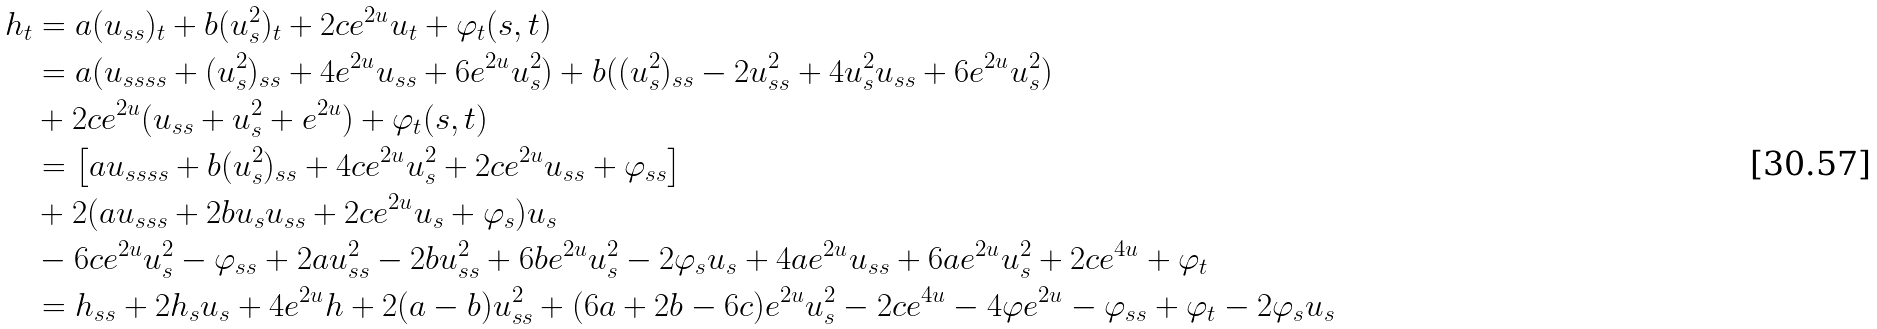Convert formula to latex. <formula><loc_0><loc_0><loc_500><loc_500>h _ { t } & = a ( u _ { s s } ) _ { t } + b ( u _ { s } ^ { 2 } ) _ { t } + 2 c e ^ { 2 u } u _ { t } + \varphi _ { t } ( s , t ) \\ & = a ( u _ { s s s s } + ( u _ { s } ^ { 2 } ) _ { s s } + 4 e ^ { 2 u } u _ { s s } + 6 e ^ { 2 u } u _ { s } ^ { 2 } ) + b ( ( u _ { s } ^ { 2 } ) _ { s s } - 2 u _ { s s } ^ { 2 } + 4 u _ { s } ^ { 2 } u _ { s s } + 6 e ^ { 2 u } u _ { s } ^ { 2 } ) \\ & + 2 c e ^ { 2 u } ( u _ { s s } + u _ { s } ^ { 2 } + e ^ { 2 u } ) + \varphi _ { t } ( s , t ) \\ & = \left [ a u _ { s s s s } + b ( u _ { s } ^ { 2 } ) _ { s s } + 4 c e ^ { 2 u } u _ { s } ^ { 2 } + 2 c e ^ { 2 u } u _ { s s } + \varphi _ { s s } \right ] \\ & + 2 ( a u _ { s s s } + 2 b u _ { s } u _ { s s } + 2 c e ^ { 2 u } u _ { s } + \varphi _ { s } ) u _ { s } \\ & - 6 c e ^ { 2 u } u _ { s } ^ { 2 } - \varphi _ { s s } + 2 a u _ { s s } ^ { 2 } - 2 b u _ { s s } ^ { 2 } + 6 b e ^ { 2 u } u _ { s } ^ { 2 } - 2 \varphi _ { s } u _ { s } + 4 a e ^ { 2 u } u _ { s s } + 6 a e ^ { 2 u } u _ { s } ^ { 2 } + 2 c e ^ { 4 u } + \varphi _ { t } \\ & = h _ { s s } + 2 h _ { s } u _ { s } + 4 e ^ { 2 u } h + 2 ( a - b ) u _ { s s } ^ { 2 } + ( 6 a + 2 b - 6 c ) e ^ { 2 u } u _ { s } ^ { 2 } - 2 c e ^ { 4 u } - 4 \varphi e ^ { 2 u } - \varphi _ { s s } + \varphi _ { t } - 2 \varphi _ { s } u _ { s }</formula> 